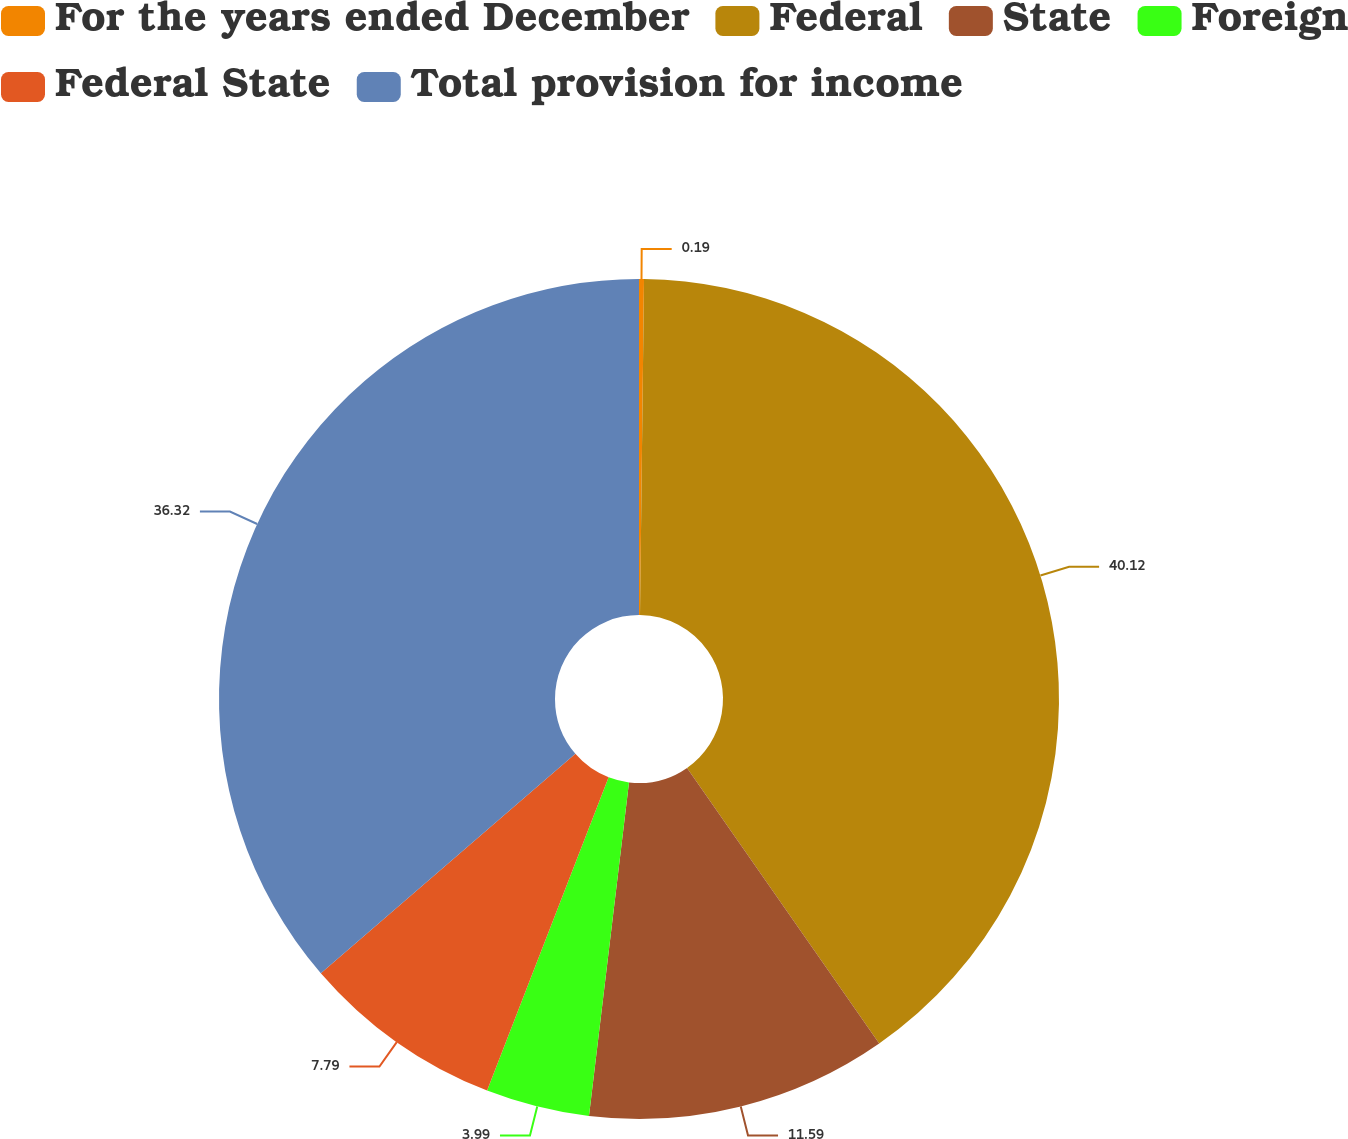<chart> <loc_0><loc_0><loc_500><loc_500><pie_chart><fcel>For the years ended December<fcel>Federal<fcel>State<fcel>Foreign<fcel>Federal State<fcel>Total provision for income<nl><fcel>0.19%<fcel>40.12%<fcel>11.59%<fcel>3.99%<fcel>7.79%<fcel>36.32%<nl></chart> 